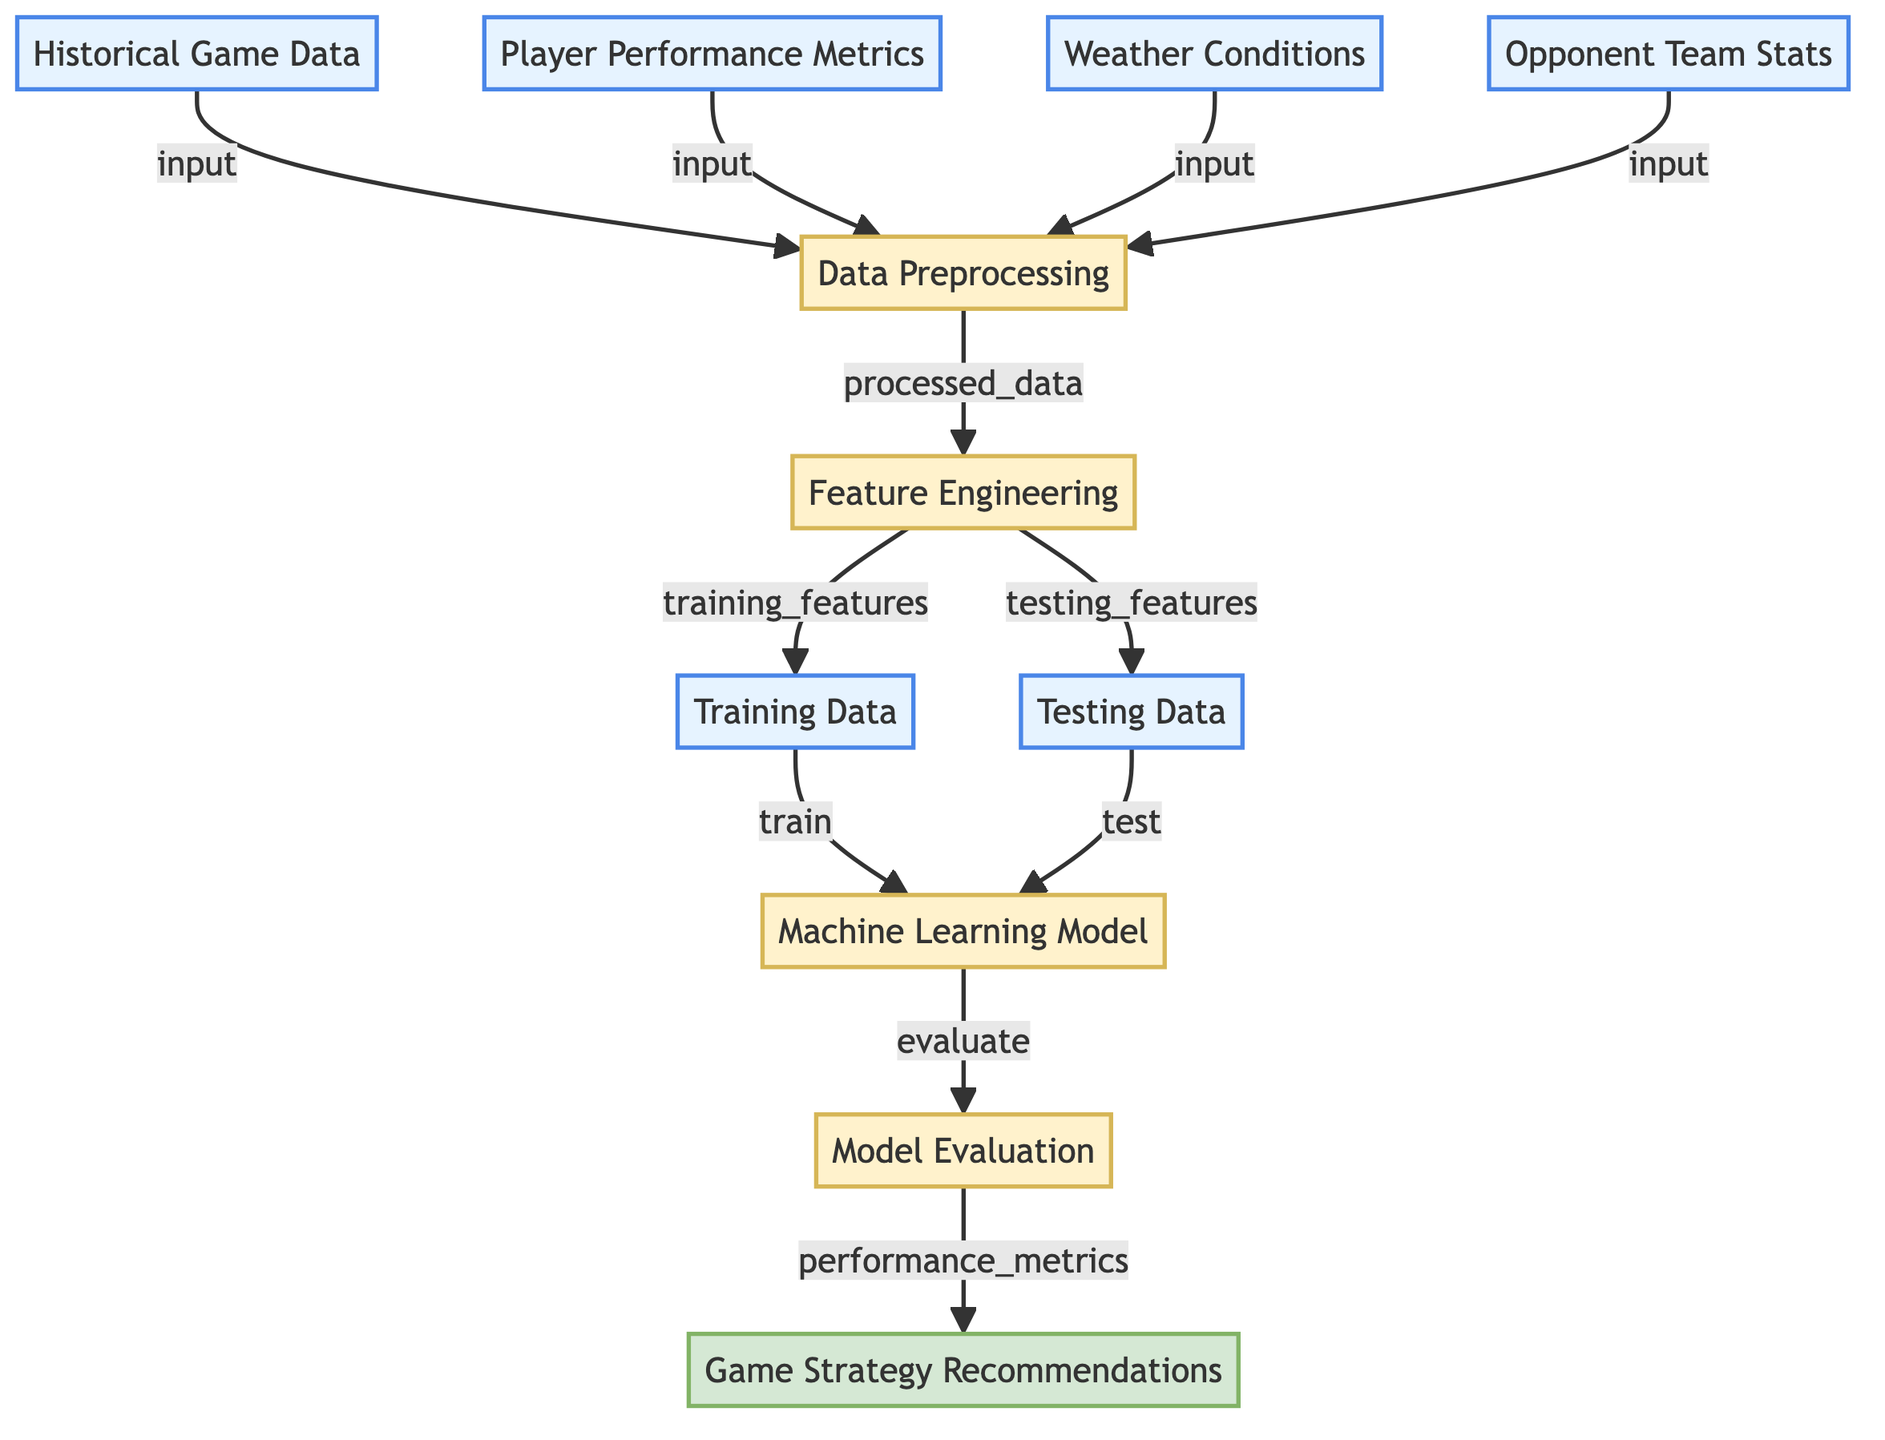What is the first step in the diagram? The first step involves the input of "Historical Game Data" which serves as one of the initial elements necessary for the data preprocessing stage.
Answer: Historical Game Data How many data sources are inputted into the data preprocessing step? There are four data sources inputted into the data preprocessing step: "Historical Game Data", "Player Performance Metrics", "Weather Conditions", and "Opponent Team Stats".
Answer: Four What does "Feature Engineering" produce? "Feature Engineering" produces "training_features" and "testing_features" which are essential for training and evaluating the machine learning model.
Answer: Training features and Testing features What is the next step after “Model Evaluation”? After "Model Evaluation", the next step is to provide "Game Strategy Recommendations" based on the performance metrics obtained from the model evaluation.
Answer: Game Strategy Recommendations Which node represents the model that will be trained? The node representing the model that will be trained is called "Machine Learning Model". This node is directly fed by the training data from the previous process.
Answer: Machine Learning Model How is "Training Data" utilized in the diagram? "Training Data" is utilized by being fed into the "Machine Learning Model" to enable the model to learn from past performance and make predictions.
Answer: Fed into the Machine Learning Model What type of data does the "Data Preprocessing" step take in? The "Data Preprocessing" step takes in historical game data, player performance metrics, weather conditions, and opponent team stats to prepare the data for analysis.
Answer: Multiple data types What happens to "Testing Data" in the flow? "Testing Data" is used to evaluate the "Machine Learning Model" to determine its performance after training has been completed with the training data.
Answer: Evaluates the Machine Learning Model 